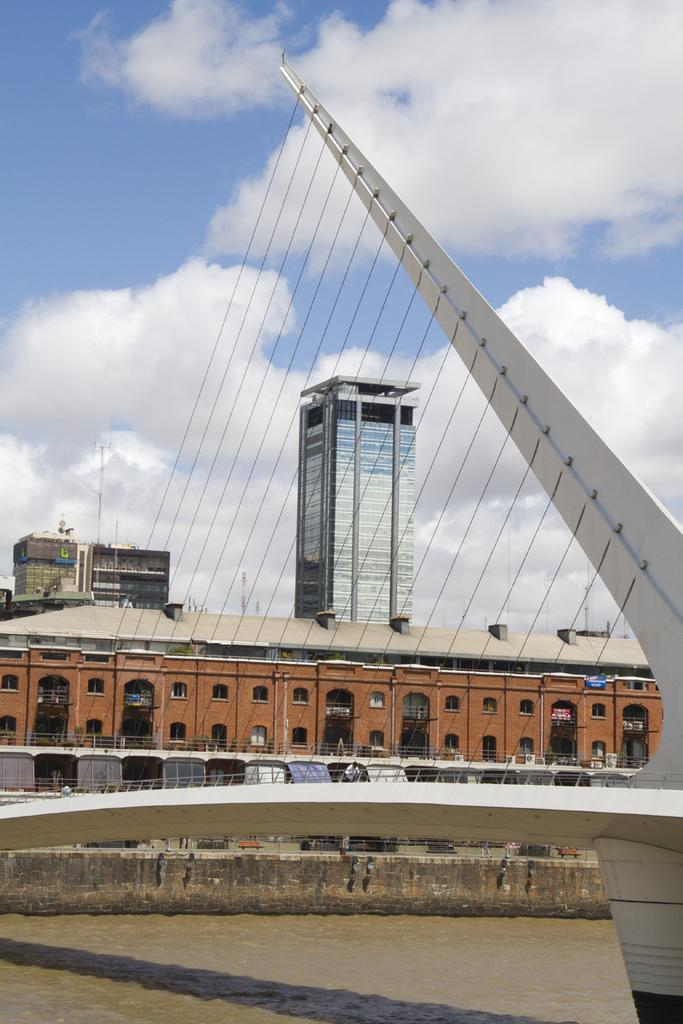What is the color of the building in the image? The building in the image is brown. What is the color of the tower in the image? The tower in the image is white. What is attached to the tower in the image? Strings are attached to the tower in the image. What is visible in the image besides the building and tower? Water is visible in the image. What can be seen in the background of the image? There is a sky with clouds in the background of the image. How much was the payment for the pin in the image? There is no pin or payment mentioned in the image; it features a brown building, a white tower with strings, water, and a sky with clouds. 